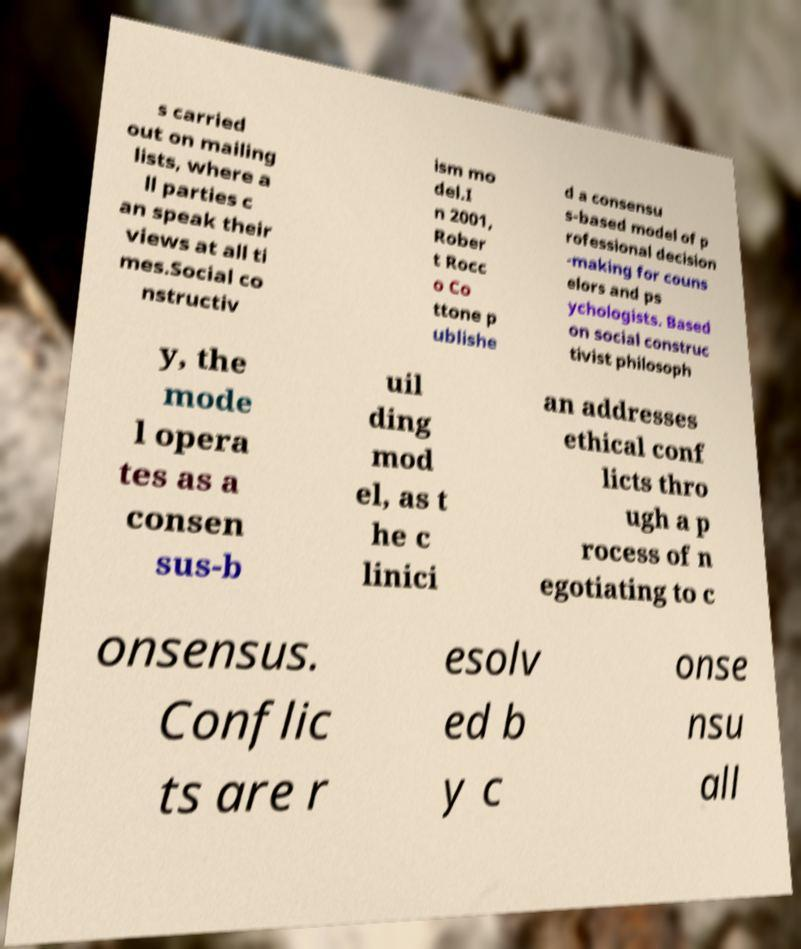Please read and relay the text visible in this image. What does it say? s carried out on mailing lists, where a ll parties c an speak their views at all ti mes.Social co nstructiv ism mo del.I n 2001, Rober t Rocc o Co ttone p ublishe d a consensu s-based model of p rofessional decision -making for couns elors and ps ychologists. Based on social construc tivist philosoph y, the mode l opera tes as a consen sus-b uil ding mod el, as t he c linici an addresses ethical conf licts thro ugh a p rocess of n egotiating to c onsensus. Conflic ts are r esolv ed b y c onse nsu all 